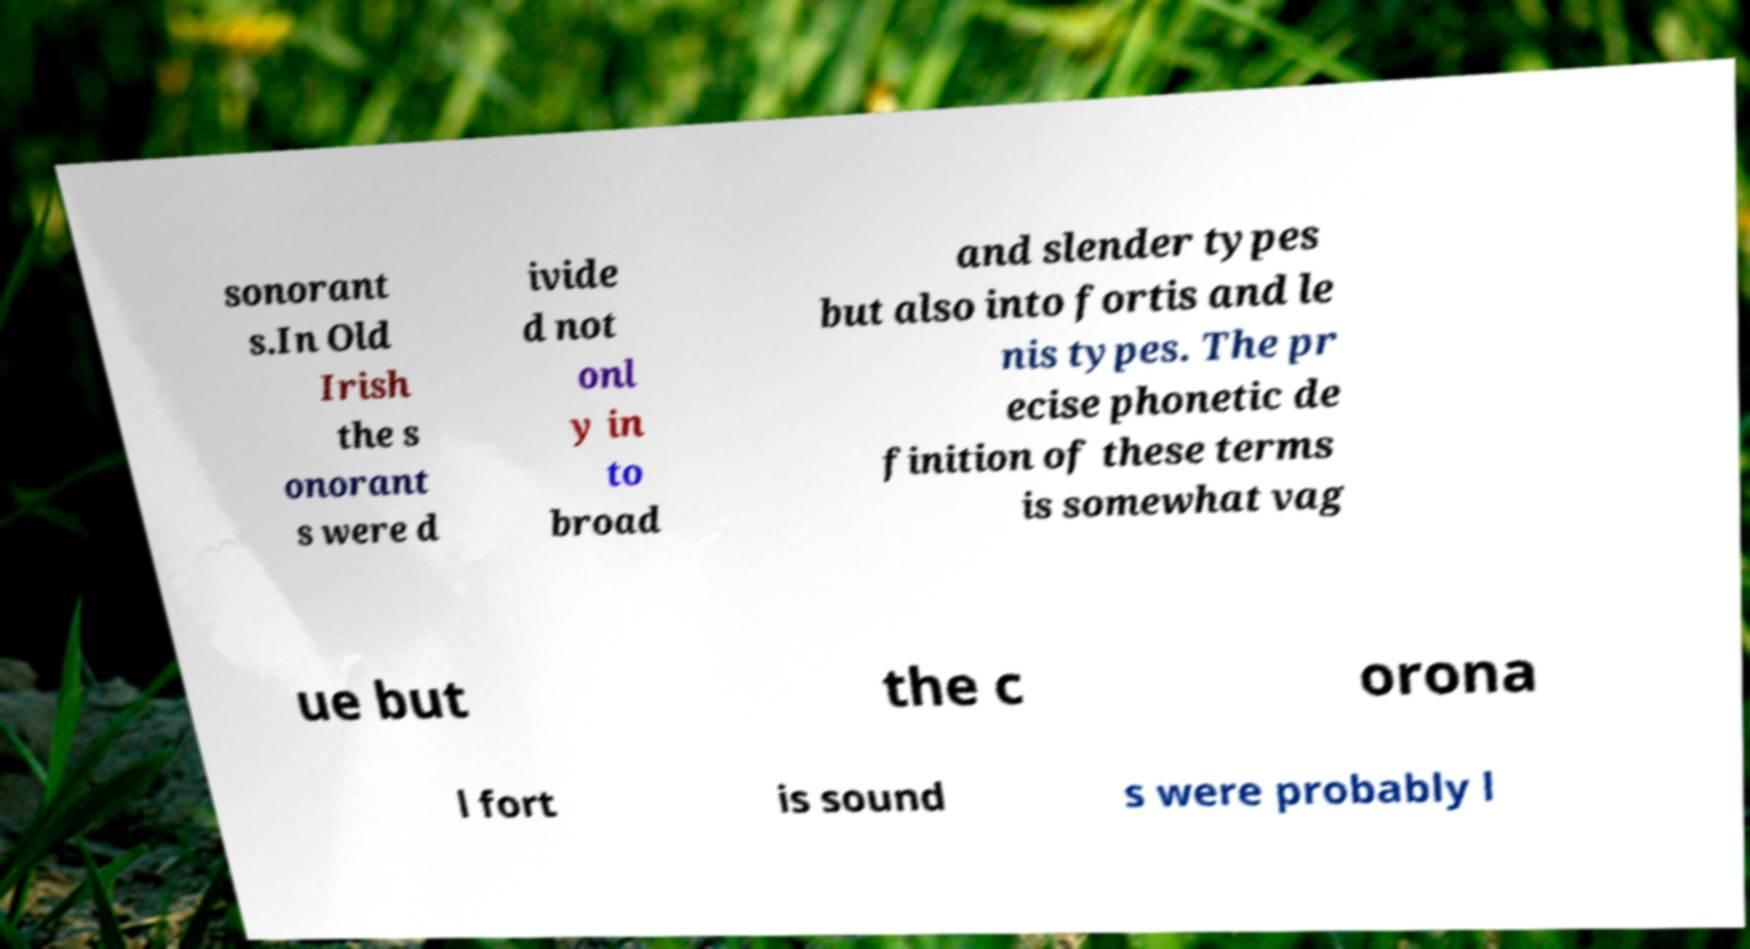Could you extract and type out the text from this image? sonorant s.In Old Irish the s onorant s were d ivide d not onl y in to broad and slender types but also into fortis and le nis types. The pr ecise phonetic de finition of these terms is somewhat vag ue but the c orona l fort is sound s were probably l 